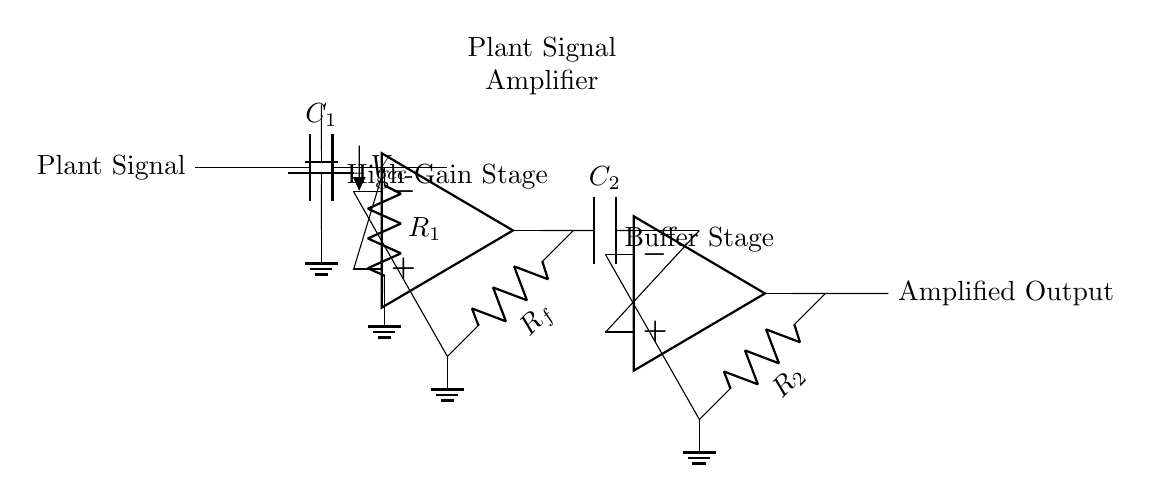What is the value of the input capacitor? The input capacitor is labeled as C1 in the circuit, which is placed in series with the plant signal. The labeling indicates its position and function in the circuit.
Answer: C1 What is the purpose of the resistors in this circuit? The resistors R1, Rf, and R2 are used for setting gain and providing feedback in the amplifier stages. R1 helps to form a high-pass filter with C1, and Rf and R2 determine the gain of their respective amplifier stages.
Answer: Gain What is the function of the op-amps in this circuit? The op-amps are used to amplify the weak plant signals. Each op-amp stage increases the signal's amplitude, making it easier to detect and analyze the electrical signals from the plants.
Answer: Amplification How many amplifier stages are present in this circuit? There are two op-amps shown in the circuit, indicating that there are two amplifier stages. Each stage contributes to the total gain of the circuit.
Answer: Two What component prevents DC offset from the signal source? The coupling capacitor C2 is positioned after the output of the first amplifier stage and prevents DC offset, allowing only AC signals to pass to the next stage. This is important for accurate signal processing.
Answer: C2 What is the output of this circuit labeled as? The output is labeled "Amplified Output," which signifies the final result of the amplification process after both stages of op-amps have operated on the signal from the plant.
Answer: Amplified Output What power supply voltage is indicated in the circuit? The power supply is labeled as Vcc, with no specific voltage value provided in the diagram. The symbol commonly represents the positive supply voltage for the op-amps.
Answer: Vcc 